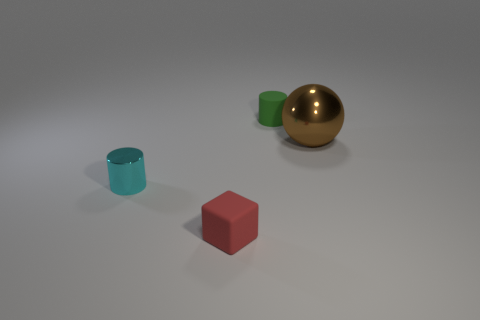The object that is behind the red thing and left of the small matte cylinder has what shape?
Your answer should be compact. Cylinder. Does the small cylinder on the left side of the small cube have the same color as the big thing?
Offer a very short reply. No. There is a thing in front of the tiny cyan cylinder; does it have the same shape as the metallic object that is left of the green thing?
Keep it short and to the point. No. What is the size of the metal thing that is on the right side of the tiny green rubber cylinder?
Offer a terse response. Large. There is a object to the right of the tiny object behind the metal sphere; what is its size?
Keep it short and to the point. Large. Is the number of tiny blue balls greater than the number of shiny cylinders?
Your answer should be compact. No. Are there more tiny green matte things in front of the cyan shiny thing than matte blocks that are right of the tiny matte block?
Keep it short and to the point. No. What size is the thing that is both in front of the matte cylinder and behind the cyan object?
Give a very brief answer. Large. What number of other brown shiny spheres are the same size as the brown sphere?
Keep it short and to the point. 0. Do the matte thing that is in front of the tiny cyan shiny cylinder and the big brown thing have the same shape?
Offer a terse response. No. 